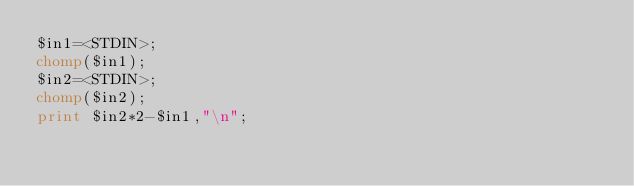<code> <loc_0><loc_0><loc_500><loc_500><_Perl_>$in1=<STDIN>;
chomp($in1);
$in2=<STDIN>;
chomp($in2);
print $in2*2-$in1,"\n";




















</code> 